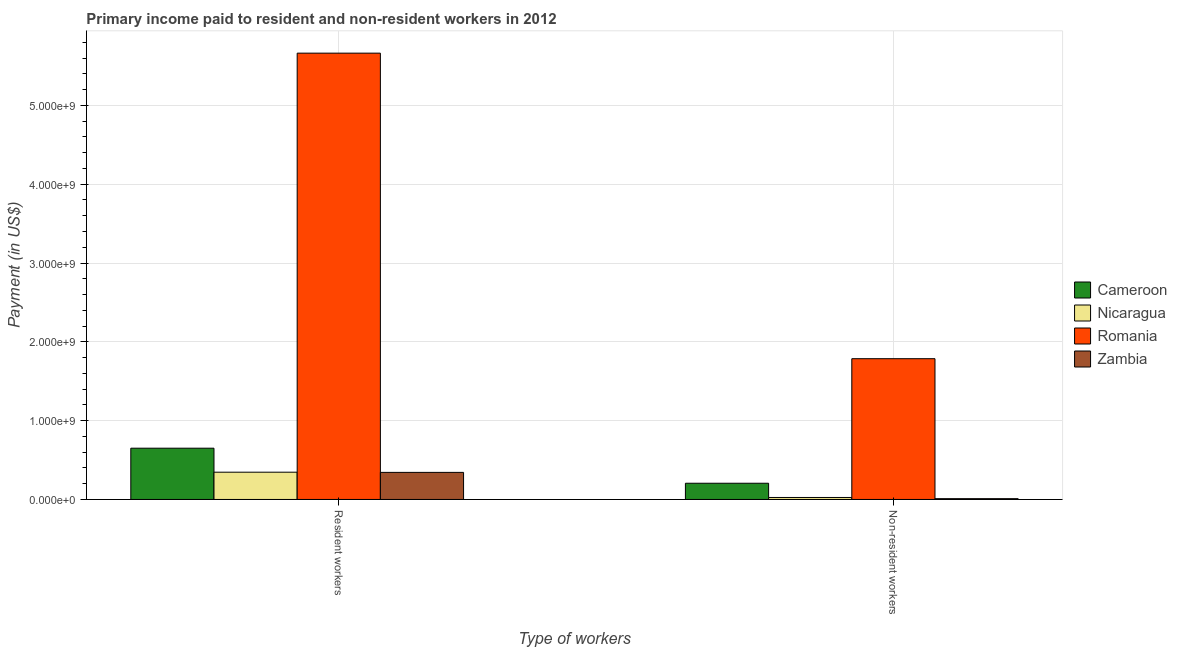How many different coloured bars are there?
Ensure brevity in your answer.  4. How many groups of bars are there?
Provide a succinct answer. 2. Are the number of bars per tick equal to the number of legend labels?
Your response must be concise. Yes. What is the label of the 1st group of bars from the left?
Your response must be concise. Resident workers. What is the payment made to non-resident workers in Zambia?
Ensure brevity in your answer.  1.01e+07. Across all countries, what is the maximum payment made to resident workers?
Provide a succinct answer. 5.66e+09. Across all countries, what is the minimum payment made to resident workers?
Your response must be concise. 3.44e+08. In which country was the payment made to resident workers maximum?
Ensure brevity in your answer.  Romania. In which country was the payment made to non-resident workers minimum?
Give a very brief answer. Zambia. What is the total payment made to non-resident workers in the graph?
Provide a succinct answer. 2.03e+09. What is the difference between the payment made to resident workers in Nicaragua and that in Romania?
Your response must be concise. -5.32e+09. What is the difference between the payment made to non-resident workers in Nicaragua and the payment made to resident workers in Cameroon?
Make the answer very short. -6.25e+08. What is the average payment made to resident workers per country?
Give a very brief answer. 1.75e+09. What is the difference between the payment made to non-resident workers and payment made to resident workers in Nicaragua?
Provide a succinct answer. -3.21e+08. What is the ratio of the payment made to non-resident workers in Romania to that in Cameroon?
Your answer should be compact. 8.68. Is the payment made to resident workers in Cameroon less than that in Romania?
Your response must be concise. Yes. What does the 3rd bar from the left in Resident workers represents?
Offer a terse response. Romania. What does the 1st bar from the right in Resident workers represents?
Your response must be concise. Zambia. How many bars are there?
Give a very brief answer. 8. Are all the bars in the graph horizontal?
Ensure brevity in your answer.  No. How many countries are there in the graph?
Provide a succinct answer. 4. Are the values on the major ticks of Y-axis written in scientific E-notation?
Ensure brevity in your answer.  Yes. Where does the legend appear in the graph?
Your answer should be very brief. Center right. How many legend labels are there?
Your answer should be compact. 4. How are the legend labels stacked?
Offer a terse response. Vertical. What is the title of the graph?
Offer a terse response. Primary income paid to resident and non-resident workers in 2012. What is the label or title of the X-axis?
Your answer should be compact. Type of workers. What is the label or title of the Y-axis?
Provide a short and direct response. Payment (in US$). What is the Payment (in US$) of Cameroon in Resident workers?
Your response must be concise. 6.50e+08. What is the Payment (in US$) of Nicaragua in Resident workers?
Make the answer very short. 3.46e+08. What is the Payment (in US$) in Romania in Resident workers?
Provide a short and direct response. 5.66e+09. What is the Payment (in US$) in Zambia in Resident workers?
Offer a very short reply. 3.44e+08. What is the Payment (in US$) of Cameroon in Non-resident workers?
Provide a succinct answer. 2.06e+08. What is the Payment (in US$) of Nicaragua in Non-resident workers?
Your answer should be very brief. 2.52e+07. What is the Payment (in US$) in Romania in Non-resident workers?
Offer a terse response. 1.79e+09. What is the Payment (in US$) in Zambia in Non-resident workers?
Ensure brevity in your answer.  1.01e+07. Across all Type of workers, what is the maximum Payment (in US$) in Cameroon?
Make the answer very short. 6.50e+08. Across all Type of workers, what is the maximum Payment (in US$) of Nicaragua?
Provide a succinct answer. 3.46e+08. Across all Type of workers, what is the maximum Payment (in US$) of Romania?
Make the answer very short. 5.66e+09. Across all Type of workers, what is the maximum Payment (in US$) in Zambia?
Provide a short and direct response. 3.44e+08. Across all Type of workers, what is the minimum Payment (in US$) in Cameroon?
Your response must be concise. 2.06e+08. Across all Type of workers, what is the minimum Payment (in US$) in Nicaragua?
Your answer should be compact. 2.52e+07. Across all Type of workers, what is the minimum Payment (in US$) of Romania?
Keep it short and to the point. 1.79e+09. Across all Type of workers, what is the minimum Payment (in US$) of Zambia?
Make the answer very short. 1.01e+07. What is the total Payment (in US$) in Cameroon in the graph?
Keep it short and to the point. 8.56e+08. What is the total Payment (in US$) of Nicaragua in the graph?
Your answer should be very brief. 3.71e+08. What is the total Payment (in US$) in Romania in the graph?
Your response must be concise. 7.45e+09. What is the total Payment (in US$) of Zambia in the graph?
Your response must be concise. 3.54e+08. What is the difference between the Payment (in US$) of Cameroon in Resident workers and that in Non-resident workers?
Your answer should be compact. 4.45e+08. What is the difference between the Payment (in US$) in Nicaragua in Resident workers and that in Non-resident workers?
Provide a succinct answer. 3.21e+08. What is the difference between the Payment (in US$) in Romania in Resident workers and that in Non-resident workers?
Your answer should be very brief. 3.88e+09. What is the difference between the Payment (in US$) of Zambia in Resident workers and that in Non-resident workers?
Offer a terse response. 3.33e+08. What is the difference between the Payment (in US$) of Cameroon in Resident workers and the Payment (in US$) of Nicaragua in Non-resident workers?
Make the answer very short. 6.25e+08. What is the difference between the Payment (in US$) of Cameroon in Resident workers and the Payment (in US$) of Romania in Non-resident workers?
Provide a short and direct response. -1.14e+09. What is the difference between the Payment (in US$) of Cameroon in Resident workers and the Payment (in US$) of Zambia in Non-resident workers?
Ensure brevity in your answer.  6.40e+08. What is the difference between the Payment (in US$) in Nicaragua in Resident workers and the Payment (in US$) in Romania in Non-resident workers?
Ensure brevity in your answer.  -1.44e+09. What is the difference between the Payment (in US$) of Nicaragua in Resident workers and the Payment (in US$) of Zambia in Non-resident workers?
Provide a succinct answer. 3.36e+08. What is the difference between the Payment (in US$) in Romania in Resident workers and the Payment (in US$) in Zambia in Non-resident workers?
Make the answer very short. 5.65e+09. What is the average Payment (in US$) in Cameroon per Type of workers?
Offer a very short reply. 4.28e+08. What is the average Payment (in US$) of Nicaragua per Type of workers?
Provide a succinct answer. 1.86e+08. What is the average Payment (in US$) in Romania per Type of workers?
Offer a terse response. 3.72e+09. What is the average Payment (in US$) in Zambia per Type of workers?
Keep it short and to the point. 1.77e+08. What is the difference between the Payment (in US$) in Cameroon and Payment (in US$) in Nicaragua in Resident workers?
Provide a succinct answer. 3.04e+08. What is the difference between the Payment (in US$) of Cameroon and Payment (in US$) of Romania in Resident workers?
Keep it short and to the point. -5.01e+09. What is the difference between the Payment (in US$) in Cameroon and Payment (in US$) in Zambia in Resident workers?
Offer a terse response. 3.07e+08. What is the difference between the Payment (in US$) in Nicaragua and Payment (in US$) in Romania in Resident workers?
Ensure brevity in your answer.  -5.32e+09. What is the difference between the Payment (in US$) in Nicaragua and Payment (in US$) in Zambia in Resident workers?
Your answer should be very brief. 2.43e+06. What is the difference between the Payment (in US$) in Romania and Payment (in US$) in Zambia in Resident workers?
Keep it short and to the point. 5.32e+09. What is the difference between the Payment (in US$) in Cameroon and Payment (in US$) in Nicaragua in Non-resident workers?
Your answer should be very brief. 1.80e+08. What is the difference between the Payment (in US$) in Cameroon and Payment (in US$) in Romania in Non-resident workers?
Provide a succinct answer. -1.58e+09. What is the difference between the Payment (in US$) in Cameroon and Payment (in US$) in Zambia in Non-resident workers?
Your answer should be compact. 1.96e+08. What is the difference between the Payment (in US$) in Nicaragua and Payment (in US$) in Romania in Non-resident workers?
Ensure brevity in your answer.  -1.76e+09. What is the difference between the Payment (in US$) in Nicaragua and Payment (in US$) in Zambia in Non-resident workers?
Your answer should be very brief. 1.51e+07. What is the difference between the Payment (in US$) of Romania and Payment (in US$) of Zambia in Non-resident workers?
Offer a terse response. 1.78e+09. What is the ratio of the Payment (in US$) in Cameroon in Resident workers to that in Non-resident workers?
Make the answer very short. 3.16. What is the ratio of the Payment (in US$) of Nicaragua in Resident workers to that in Non-resident workers?
Provide a short and direct response. 13.73. What is the ratio of the Payment (in US$) of Romania in Resident workers to that in Non-resident workers?
Provide a short and direct response. 3.17. What is the ratio of the Payment (in US$) of Zambia in Resident workers to that in Non-resident workers?
Make the answer very short. 34.04. What is the difference between the highest and the second highest Payment (in US$) in Cameroon?
Your answer should be very brief. 4.45e+08. What is the difference between the highest and the second highest Payment (in US$) in Nicaragua?
Offer a very short reply. 3.21e+08. What is the difference between the highest and the second highest Payment (in US$) of Romania?
Give a very brief answer. 3.88e+09. What is the difference between the highest and the second highest Payment (in US$) in Zambia?
Provide a succinct answer. 3.33e+08. What is the difference between the highest and the lowest Payment (in US$) in Cameroon?
Make the answer very short. 4.45e+08. What is the difference between the highest and the lowest Payment (in US$) in Nicaragua?
Give a very brief answer. 3.21e+08. What is the difference between the highest and the lowest Payment (in US$) in Romania?
Keep it short and to the point. 3.88e+09. What is the difference between the highest and the lowest Payment (in US$) of Zambia?
Offer a terse response. 3.33e+08. 